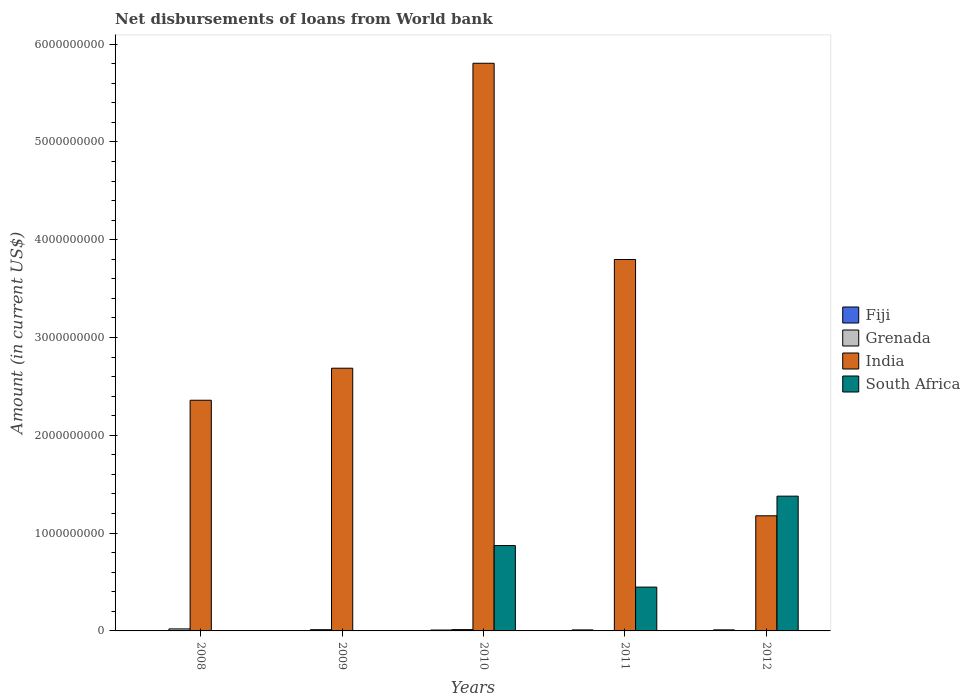How many different coloured bars are there?
Offer a terse response. 4. Are the number of bars per tick equal to the number of legend labels?
Ensure brevity in your answer.  No. How many bars are there on the 1st tick from the left?
Your answer should be compact. 3. What is the label of the 3rd group of bars from the left?
Offer a terse response. 2010. What is the amount of loan disbursed from World Bank in Grenada in 2010?
Your response must be concise. 1.34e+07. Across all years, what is the maximum amount of loan disbursed from World Bank in India?
Provide a short and direct response. 5.80e+09. Across all years, what is the minimum amount of loan disbursed from World Bank in India?
Ensure brevity in your answer.  1.18e+09. In which year was the amount of loan disbursed from World Bank in Fiji maximum?
Offer a terse response. 2012. What is the total amount of loan disbursed from World Bank in Grenada in the graph?
Offer a terse response. 4.96e+07. What is the difference between the amount of loan disbursed from World Bank in Fiji in 2011 and that in 2012?
Your answer should be very brief. -5.00e+05. What is the difference between the amount of loan disbursed from World Bank in South Africa in 2008 and the amount of loan disbursed from World Bank in Grenada in 2012?
Give a very brief answer. -2.82e+06. What is the average amount of loan disbursed from World Bank in India per year?
Your response must be concise. 3.16e+09. In the year 2012, what is the difference between the amount of loan disbursed from World Bank in Fiji and amount of loan disbursed from World Bank in Grenada?
Your answer should be very brief. 7.92e+06. What is the ratio of the amount of loan disbursed from World Bank in India in 2008 to that in 2012?
Your response must be concise. 2. Is the amount of loan disbursed from World Bank in India in 2009 less than that in 2010?
Keep it short and to the point. Yes. What is the difference between the highest and the second highest amount of loan disbursed from World Bank in South Africa?
Offer a terse response. 5.05e+08. What is the difference between the highest and the lowest amount of loan disbursed from World Bank in Fiji?
Keep it short and to the point. 1.07e+07. In how many years, is the amount of loan disbursed from World Bank in South Africa greater than the average amount of loan disbursed from World Bank in South Africa taken over all years?
Keep it short and to the point. 2. Is it the case that in every year, the sum of the amount of loan disbursed from World Bank in Grenada and amount of loan disbursed from World Bank in South Africa is greater than the sum of amount of loan disbursed from World Bank in Fiji and amount of loan disbursed from World Bank in India?
Your answer should be very brief. No. Is it the case that in every year, the sum of the amount of loan disbursed from World Bank in India and amount of loan disbursed from World Bank in Fiji is greater than the amount of loan disbursed from World Bank in Grenada?
Make the answer very short. Yes. Are all the bars in the graph horizontal?
Provide a short and direct response. No. What is the difference between two consecutive major ticks on the Y-axis?
Give a very brief answer. 1.00e+09. Are the values on the major ticks of Y-axis written in scientific E-notation?
Provide a succinct answer. No. How many legend labels are there?
Give a very brief answer. 4. What is the title of the graph?
Ensure brevity in your answer.  Net disbursements of loans from World bank. Does "Low income" appear as one of the legend labels in the graph?
Make the answer very short. No. What is the Amount (in current US$) in Fiji in 2008?
Make the answer very short. 3.70e+06. What is the Amount (in current US$) in Grenada in 2008?
Keep it short and to the point. 2.07e+07. What is the Amount (in current US$) in India in 2008?
Provide a succinct answer. 2.36e+09. What is the Amount (in current US$) in Fiji in 2009?
Offer a terse response. 0. What is the Amount (in current US$) in Grenada in 2009?
Your response must be concise. 1.27e+07. What is the Amount (in current US$) in India in 2009?
Provide a succinct answer. 2.69e+09. What is the Amount (in current US$) in Fiji in 2010?
Keep it short and to the point. 9.04e+06. What is the Amount (in current US$) of Grenada in 2010?
Offer a terse response. 1.34e+07. What is the Amount (in current US$) in India in 2010?
Ensure brevity in your answer.  5.80e+09. What is the Amount (in current US$) in South Africa in 2010?
Offer a terse response. 8.73e+08. What is the Amount (in current US$) of Fiji in 2011?
Your response must be concise. 1.02e+07. What is the Amount (in current US$) of Grenada in 2011?
Keep it short and to the point. 0. What is the Amount (in current US$) of India in 2011?
Your response must be concise. 3.80e+09. What is the Amount (in current US$) of South Africa in 2011?
Ensure brevity in your answer.  4.48e+08. What is the Amount (in current US$) of Fiji in 2012?
Your answer should be compact. 1.07e+07. What is the Amount (in current US$) of Grenada in 2012?
Your response must be concise. 2.82e+06. What is the Amount (in current US$) in India in 2012?
Offer a very short reply. 1.18e+09. What is the Amount (in current US$) of South Africa in 2012?
Offer a very short reply. 1.38e+09. Across all years, what is the maximum Amount (in current US$) in Fiji?
Give a very brief answer. 1.07e+07. Across all years, what is the maximum Amount (in current US$) in Grenada?
Offer a terse response. 2.07e+07. Across all years, what is the maximum Amount (in current US$) of India?
Offer a terse response. 5.80e+09. Across all years, what is the maximum Amount (in current US$) of South Africa?
Provide a short and direct response. 1.38e+09. Across all years, what is the minimum Amount (in current US$) of Fiji?
Make the answer very short. 0. Across all years, what is the minimum Amount (in current US$) in Grenada?
Your answer should be very brief. 0. Across all years, what is the minimum Amount (in current US$) of India?
Your response must be concise. 1.18e+09. Across all years, what is the minimum Amount (in current US$) in South Africa?
Offer a very short reply. 0. What is the total Amount (in current US$) in Fiji in the graph?
Provide a short and direct response. 3.37e+07. What is the total Amount (in current US$) in Grenada in the graph?
Your answer should be very brief. 4.96e+07. What is the total Amount (in current US$) in India in the graph?
Your answer should be very brief. 1.58e+1. What is the total Amount (in current US$) of South Africa in the graph?
Keep it short and to the point. 2.70e+09. What is the difference between the Amount (in current US$) of Grenada in 2008 and that in 2009?
Provide a succinct answer. 7.99e+06. What is the difference between the Amount (in current US$) in India in 2008 and that in 2009?
Keep it short and to the point. -3.28e+08. What is the difference between the Amount (in current US$) in Fiji in 2008 and that in 2010?
Your answer should be compact. -5.34e+06. What is the difference between the Amount (in current US$) of Grenada in 2008 and that in 2010?
Provide a succinct answer. 7.23e+06. What is the difference between the Amount (in current US$) in India in 2008 and that in 2010?
Make the answer very short. -3.45e+09. What is the difference between the Amount (in current US$) in Fiji in 2008 and that in 2011?
Provide a short and direct response. -6.54e+06. What is the difference between the Amount (in current US$) of India in 2008 and that in 2011?
Make the answer very short. -1.44e+09. What is the difference between the Amount (in current US$) in Fiji in 2008 and that in 2012?
Provide a succinct answer. -7.04e+06. What is the difference between the Amount (in current US$) of Grenada in 2008 and that in 2012?
Offer a terse response. 1.78e+07. What is the difference between the Amount (in current US$) of India in 2008 and that in 2012?
Your answer should be compact. 1.18e+09. What is the difference between the Amount (in current US$) of Grenada in 2009 and that in 2010?
Your response must be concise. -7.53e+05. What is the difference between the Amount (in current US$) of India in 2009 and that in 2010?
Your response must be concise. -3.12e+09. What is the difference between the Amount (in current US$) in India in 2009 and that in 2011?
Your answer should be very brief. -1.11e+09. What is the difference between the Amount (in current US$) in Grenada in 2009 and that in 2012?
Your answer should be compact. 9.84e+06. What is the difference between the Amount (in current US$) in India in 2009 and that in 2012?
Offer a very short reply. 1.51e+09. What is the difference between the Amount (in current US$) in Fiji in 2010 and that in 2011?
Ensure brevity in your answer.  -1.20e+06. What is the difference between the Amount (in current US$) in India in 2010 and that in 2011?
Keep it short and to the point. 2.01e+09. What is the difference between the Amount (in current US$) of South Africa in 2010 and that in 2011?
Your answer should be compact. 4.25e+08. What is the difference between the Amount (in current US$) in Fiji in 2010 and that in 2012?
Provide a succinct answer. -1.70e+06. What is the difference between the Amount (in current US$) of Grenada in 2010 and that in 2012?
Provide a succinct answer. 1.06e+07. What is the difference between the Amount (in current US$) in India in 2010 and that in 2012?
Provide a short and direct response. 4.63e+09. What is the difference between the Amount (in current US$) in South Africa in 2010 and that in 2012?
Your response must be concise. -5.05e+08. What is the difference between the Amount (in current US$) of Fiji in 2011 and that in 2012?
Provide a succinct answer. -5.00e+05. What is the difference between the Amount (in current US$) in India in 2011 and that in 2012?
Your answer should be compact. 2.62e+09. What is the difference between the Amount (in current US$) in South Africa in 2011 and that in 2012?
Keep it short and to the point. -9.30e+08. What is the difference between the Amount (in current US$) of Fiji in 2008 and the Amount (in current US$) of Grenada in 2009?
Give a very brief answer. -8.97e+06. What is the difference between the Amount (in current US$) of Fiji in 2008 and the Amount (in current US$) of India in 2009?
Your answer should be very brief. -2.68e+09. What is the difference between the Amount (in current US$) of Grenada in 2008 and the Amount (in current US$) of India in 2009?
Provide a succinct answer. -2.67e+09. What is the difference between the Amount (in current US$) in Fiji in 2008 and the Amount (in current US$) in Grenada in 2010?
Offer a terse response. -9.72e+06. What is the difference between the Amount (in current US$) in Fiji in 2008 and the Amount (in current US$) in India in 2010?
Keep it short and to the point. -5.80e+09. What is the difference between the Amount (in current US$) of Fiji in 2008 and the Amount (in current US$) of South Africa in 2010?
Ensure brevity in your answer.  -8.69e+08. What is the difference between the Amount (in current US$) of Grenada in 2008 and the Amount (in current US$) of India in 2010?
Provide a succinct answer. -5.78e+09. What is the difference between the Amount (in current US$) in Grenada in 2008 and the Amount (in current US$) in South Africa in 2010?
Ensure brevity in your answer.  -8.52e+08. What is the difference between the Amount (in current US$) in India in 2008 and the Amount (in current US$) in South Africa in 2010?
Your answer should be compact. 1.49e+09. What is the difference between the Amount (in current US$) in Fiji in 2008 and the Amount (in current US$) in India in 2011?
Give a very brief answer. -3.79e+09. What is the difference between the Amount (in current US$) of Fiji in 2008 and the Amount (in current US$) of South Africa in 2011?
Your answer should be compact. -4.44e+08. What is the difference between the Amount (in current US$) in Grenada in 2008 and the Amount (in current US$) in India in 2011?
Ensure brevity in your answer.  -3.78e+09. What is the difference between the Amount (in current US$) of Grenada in 2008 and the Amount (in current US$) of South Africa in 2011?
Give a very brief answer. -4.27e+08. What is the difference between the Amount (in current US$) of India in 2008 and the Amount (in current US$) of South Africa in 2011?
Your answer should be compact. 1.91e+09. What is the difference between the Amount (in current US$) in Fiji in 2008 and the Amount (in current US$) in Grenada in 2012?
Provide a short and direct response. 8.73e+05. What is the difference between the Amount (in current US$) in Fiji in 2008 and the Amount (in current US$) in India in 2012?
Your answer should be compact. -1.17e+09. What is the difference between the Amount (in current US$) of Fiji in 2008 and the Amount (in current US$) of South Africa in 2012?
Give a very brief answer. -1.37e+09. What is the difference between the Amount (in current US$) in Grenada in 2008 and the Amount (in current US$) in India in 2012?
Make the answer very short. -1.16e+09. What is the difference between the Amount (in current US$) of Grenada in 2008 and the Amount (in current US$) of South Africa in 2012?
Ensure brevity in your answer.  -1.36e+09. What is the difference between the Amount (in current US$) in India in 2008 and the Amount (in current US$) in South Africa in 2012?
Ensure brevity in your answer.  9.81e+08. What is the difference between the Amount (in current US$) of Grenada in 2009 and the Amount (in current US$) of India in 2010?
Your answer should be compact. -5.79e+09. What is the difference between the Amount (in current US$) of Grenada in 2009 and the Amount (in current US$) of South Africa in 2010?
Make the answer very short. -8.60e+08. What is the difference between the Amount (in current US$) of India in 2009 and the Amount (in current US$) of South Africa in 2010?
Your response must be concise. 1.81e+09. What is the difference between the Amount (in current US$) of Grenada in 2009 and the Amount (in current US$) of India in 2011?
Your answer should be very brief. -3.78e+09. What is the difference between the Amount (in current US$) of Grenada in 2009 and the Amount (in current US$) of South Africa in 2011?
Keep it short and to the point. -4.35e+08. What is the difference between the Amount (in current US$) of India in 2009 and the Amount (in current US$) of South Africa in 2011?
Give a very brief answer. 2.24e+09. What is the difference between the Amount (in current US$) of Grenada in 2009 and the Amount (in current US$) of India in 2012?
Your answer should be very brief. -1.16e+09. What is the difference between the Amount (in current US$) in Grenada in 2009 and the Amount (in current US$) in South Africa in 2012?
Offer a terse response. -1.37e+09. What is the difference between the Amount (in current US$) in India in 2009 and the Amount (in current US$) in South Africa in 2012?
Give a very brief answer. 1.31e+09. What is the difference between the Amount (in current US$) of Fiji in 2010 and the Amount (in current US$) of India in 2011?
Offer a very short reply. -3.79e+09. What is the difference between the Amount (in current US$) in Fiji in 2010 and the Amount (in current US$) in South Africa in 2011?
Your answer should be very brief. -4.39e+08. What is the difference between the Amount (in current US$) in Grenada in 2010 and the Amount (in current US$) in India in 2011?
Your answer should be very brief. -3.78e+09. What is the difference between the Amount (in current US$) of Grenada in 2010 and the Amount (in current US$) of South Africa in 2011?
Make the answer very short. -4.35e+08. What is the difference between the Amount (in current US$) of India in 2010 and the Amount (in current US$) of South Africa in 2011?
Ensure brevity in your answer.  5.36e+09. What is the difference between the Amount (in current US$) of Fiji in 2010 and the Amount (in current US$) of Grenada in 2012?
Provide a short and direct response. 6.22e+06. What is the difference between the Amount (in current US$) in Fiji in 2010 and the Amount (in current US$) in India in 2012?
Offer a terse response. -1.17e+09. What is the difference between the Amount (in current US$) of Fiji in 2010 and the Amount (in current US$) of South Africa in 2012?
Give a very brief answer. -1.37e+09. What is the difference between the Amount (in current US$) of Grenada in 2010 and the Amount (in current US$) of India in 2012?
Make the answer very short. -1.16e+09. What is the difference between the Amount (in current US$) in Grenada in 2010 and the Amount (in current US$) in South Africa in 2012?
Your answer should be compact. -1.36e+09. What is the difference between the Amount (in current US$) in India in 2010 and the Amount (in current US$) in South Africa in 2012?
Give a very brief answer. 4.43e+09. What is the difference between the Amount (in current US$) in Fiji in 2011 and the Amount (in current US$) in Grenada in 2012?
Keep it short and to the point. 7.42e+06. What is the difference between the Amount (in current US$) in Fiji in 2011 and the Amount (in current US$) in India in 2012?
Give a very brief answer. -1.17e+09. What is the difference between the Amount (in current US$) in Fiji in 2011 and the Amount (in current US$) in South Africa in 2012?
Provide a short and direct response. -1.37e+09. What is the difference between the Amount (in current US$) of India in 2011 and the Amount (in current US$) of South Africa in 2012?
Your answer should be very brief. 2.42e+09. What is the average Amount (in current US$) in Fiji per year?
Provide a short and direct response. 6.74e+06. What is the average Amount (in current US$) in Grenada per year?
Your answer should be very brief. 9.91e+06. What is the average Amount (in current US$) in India per year?
Give a very brief answer. 3.16e+09. What is the average Amount (in current US$) in South Africa per year?
Keep it short and to the point. 5.40e+08. In the year 2008, what is the difference between the Amount (in current US$) of Fiji and Amount (in current US$) of Grenada?
Your answer should be very brief. -1.70e+07. In the year 2008, what is the difference between the Amount (in current US$) in Fiji and Amount (in current US$) in India?
Your answer should be very brief. -2.35e+09. In the year 2008, what is the difference between the Amount (in current US$) in Grenada and Amount (in current US$) in India?
Provide a succinct answer. -2.34e+09. In the year 2009, what is the difference between the Amount (in current US$) of Grenada and Amount (in current US$) of India?
Offer a terse response. -2.67e+09. In the year 2010, what is the difference between the Amount (in current US$) of Fiji and Amount (in current US$) of Grenada?
Offer a very short reply. -4.38e+06. In the year 2010, what is the difference between the Amount (in current US$) in Fiji and Amount (in current US$) in India?
Keep it short and to the point. -5.79e+09. In the year 2010, what is the difference between the Amount (in current US$) of Fiji and Amount (in current US$) of South Africa?
Keep it short and to the point. -8.64e+08. In the year 2010, what is the difference between the Amount (in current US$) in Grenada and Amount (in current US$) in India?
Provide a short and direct response. -5.79e+09. In the year 2010, what is the difference between the Amount (in current US$) in Grenada and Amount (in current US$) in South Africa?
Your answer should be compact. -8.59e+08. In the year 2010, what is the difference between the Amount (in current US$) of India and Amount (in current US$) of South Africa?
Offer a very short reply. 4.93e+09. In the year 2011, what is the difference between the Amount (in current US$) in Fiji and Amount (in current US$) in India?
Your response must be concise. -3.79e+09. In the year 2011, what is the difference between the Amount (in current US$) of Fiji and Amount (in current US$) of South Africa?
Provide a short and direct response. -4.38e+08. In the year 2011, what is the difference between the Amount (in current US$) in India and Amount (in current US$) in South Africa?
Keep it short and to the point. 3.35e+09. In the year 2012, what is the difference between the Amount (in current US$) in Fiji and Amount (in current US$) in Grenada?
Provide a short and direct response. 7.92e+06. In the year 2012, what is the difference between the Amount (in current US$) of Fiji and Amount (in current US$) of India?
Give a very brief answer. -1.17e+09. In the year 2012, what is the difference between the Amount (in current US$) in Fiji and Amount (in current US$) in South Africa?
Provide a short and direct response. -1.37e+09. In the year 2012, what is the difference between the Amount (in current US$) of Grenada and Amount (in current US$) of India?
Keep it short and to the point. -1.17e+09. In the year 2012, what is the difference between the Amount (in current US$) in Grenada and Amount (in current US$) in South Africa?
Make the answer very short. -1.38e+09. In the year 2012, what is the difference between the Amount (in current US$) in India and Amount (in current US$) in South Africa?
Offer a very short reply. -2.01e+08. What is the ratio of the Amount (in current US$) of Grenada in 2008 to that in 2009?
Give a very brief answer. 1.63. What is the ratio of the Amount (in current US$) of India in 2008 to that in 2009?
Ensure brevity in your answer.  0.88. What is the ratio of the Amount (in current US$) of Fiji in 2008 to that in 2010?
Your answer should be compact. 0.41. What is the ratio of the Amount (in current US$) in Grenada in 2008 to that in 2010?
Provide a succinct answer. 1.54. What is the ratio of the Amount (in current US$) of India in 2008 to that in 2010?
Make the answer very short. 0.41. What is the ratio of the Amount (in current US$) of Fiji in 2008 to that in 2011?
Your answer should be compact. 0.36. What is the ratio of the Amount (in current US$) of India in 2008 to that in 2011?
Give a very brief answer. 0.62. What is the ratio of the Amount (in current US$) of Fiji in 2008 to that in 2012?
Your response must be concise. 0.34. What is the ratio of the Amount (in current US$) of Grenada in 2008 to that in 2012?
Provide a succinct answer. 7.31. What is the ratio of the Amount (in current US$) of India in 2008 to that in 2012?
Your answer should be compact. 2. What is the ratio of the Amount (in current US$) in Grenada in 2009 to that in 2010?
Offer a very short reply. 0.94. What is the ratio of the Amount (in current US$) of India in 2009 to that in 2010?
Keep it short and to the point. 0.46. What is the ratio of the Amount (in current US$) in India in 2009 to that in 2011?
Provide a succinct answer. 0.71. What is the ratio of the Amount (in current US$) of Grenada in 2009 to that in 2012?
Make the answer very short. 4.48. What is the ratio of the Amount (in current US$) in India in 2009 to that in 2012?
Ensure brevity in your answer.  2.28. What is the ratio of the Amount (in current US$) in Fiji in 2010 to that in 2011?
Ensure brevity in your answer.  0.88. What is the ratio of the Amount (in current US$) in India in 2010 to that in 2011?
Your response must be concise. 1.53. What is the ratio of the Amount (in current US$) of South Africa in 2010 to that in 2011?
Your response must be concise. 1.95. What is the ratio of the Amount (in current US$) in Fiji in 2010 to that in 2012?
Keep it short and to the point. 0.84. What is the ratio of the Amount (in current US$) of Grenada in 2010 to that in 2012?
Your answer should be very brief. 4.75. What is the ratio of the Amount (in current US$) of India in 2010 to that in 2012?
Ensure brevity in your answer.  4.93. What is the ratio of the Amount (in current US$) in South Africa in 2010 to that in 2012?
Your response must be concise. 0.63. What is the ratio of the Amount (in current US$) in Fiji in 2011 to that in 2012?
Your response must be concise. 0.95. What is the ratio of the Amount (in current US$) of India in 2011 to that in 2012?
Offer a very short reply. 3.23. What is the ratio of the Amount (in current US$) of South Africa in 2011 to that in 2012?
Your response must be concise. 0.33. What is the difference between the highest and the second highest Amount (in current US$) of Fiji?
Your answer should be compact. 5.00e+05. What is the difference between the highest and the second highest Amount (in current US$) in Grenada?
Provide a succinct answer. 7.23e+06. What is the difference between the highest and the second highest Amount (in current US$) in India?
Your response must be concise. 2.01e+09. What is the difference between the highest and the second highest Amount (in current US$) in South Africa?
Give a very brief answer. 5.05e+08. What is the difference between the highest and the lowest Amount (in current US$) of Fiji?
Your response must be concise. 1.07e+07. What is the difference between the highest and the lowest Amount (in current US$) of Grenada?
Offer a very short reply. 2.07e+07. What is the difference between the highest and the lowest Amount (in current US$) of India?
Your answer should be very brief. 4.63e+09. What is the difference between the highest and the lowest Amount (in current US$) in South Africa?
Offer a terse response. 1.38e+09. 